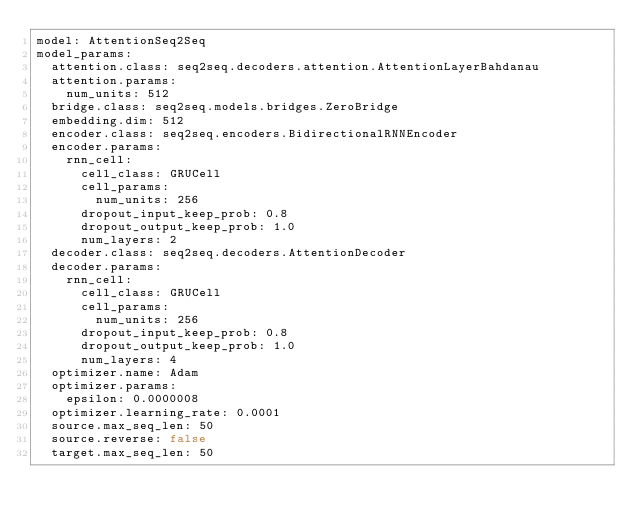Convert code to text. <code><loc_0><loc_0><loc_500><loc_500><_YAML_>model: AttentionSeq2Seq
model_params:
  attention.class: seq2seq.decoders.attention.AttentionLayerBahdanau
  attention.params:
    num_units: 512
  bridge.class: seq2seq.models.bridges.ZeroBridge
  embedding.dim: 512
  encoder.class: seq2seq.encoders.BidirectionalRNNEncoder
  encoder.params:
    rnn_cell:
      cell_class: GRUCell
      cell_params:
        num_units: 256
      dropout_input_keep_prob: 0.8
      dropout_output_keep_prob: 1.0
      num_layers: 2
  decoder.class: seq2seq.decoders.AttentionDecoder
  decoder.params:
    rnn_cell:
      cell_class: GRUCell
      cell_params:
        num_units: 256
      dropout_input_keep_prob: 0.8
      dropout_output_keep_prob: 1.0
      num_layers: 4
  optimizer.name: Adam
  optimizer.params:
    epsilon: 0.0000008
  optimizer.learning_rate: 0.0001
  source.max_seq_len: 50
  source.reverse: false
  target.max_seq_len: 50
</code> 